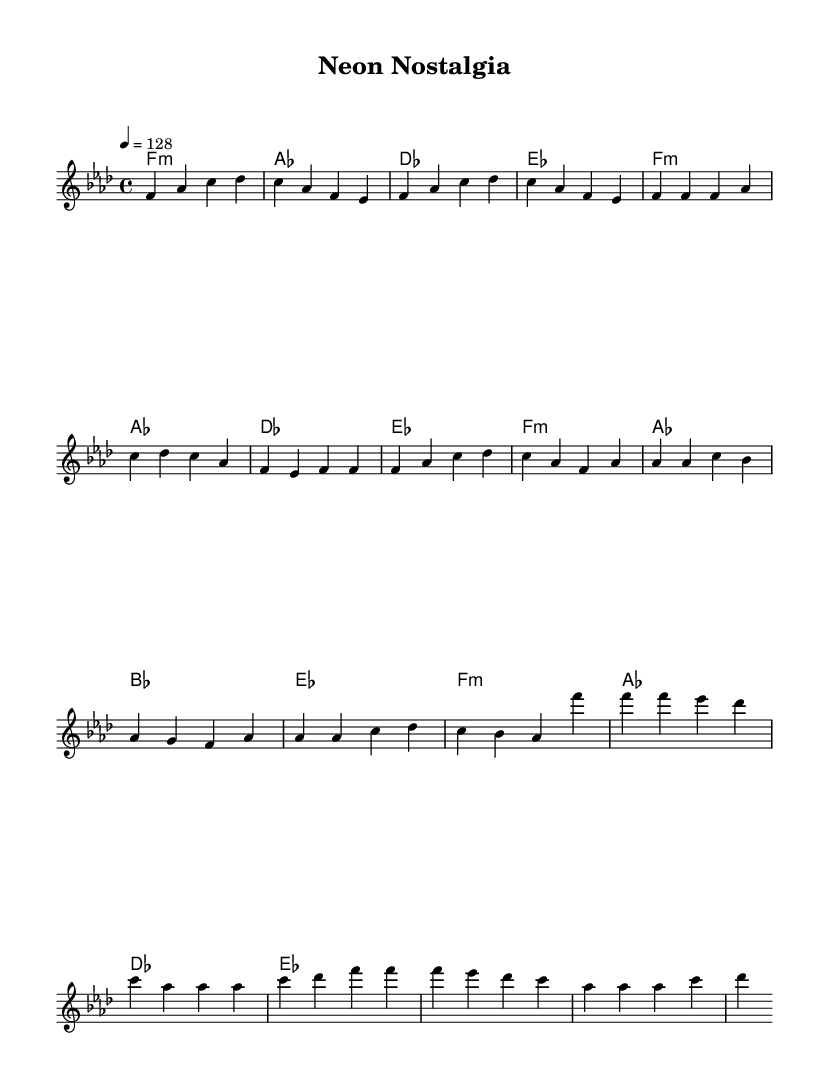What is the key signature of this music? The key signature is F minor, which has four flats (B, E, A, and D). This can be determined by looking at the key signature indicated at the beginning of the score, marked with the appropriate flat symbols.
Answer: F minor What is the time signature of the piece? The time signature is 4/4, which is a common time signature indicating that there are four beats in each measure and a quarter note receives one beat. This can be found at the beginning of the score next to the key signature.
Answer: 4/4 What is the tempo marking for this music? The tempo marking is 128 beats per minute, which is indicated in the score. It guides the performer on how fast to play the piece, giving it a lively dance feel typical in electronic dance music.
Answer: 128 How many measures are in the chorus? There are four measures in the chorus section, which is noted in the sheet music where the 'Chorus' section begins. The melody and harmony show a consistent pattern over four measures, clearly delineating this part of the song.
Answer: 4 What type of harmony is predominantly used in this piece? The harmony predominantly used in this piece is minor chords, as seen in the chord symbols listed. This creates a darker, more intense emotional quality often associated with rave culture and electronic music.
Answer: Minor Which section features ascending melodies? The Pre-chorus section features ascending melodies, particularly evident when the melody reaches higher pitches towards the end of that part. This builds energy leading into the chorus, a common technique in electronic and K-Pop music.
Answer: Pre-chorus What rhythmic feel does this score emphasize? The score emphasizes a steady, driving rhythm typical of electronic dance music, achieved through the consistent eighth-note patterns in the melody combined with the driving quarter-note pulse in the harmony. This creates a danceable feel.
Answer: Danceable 